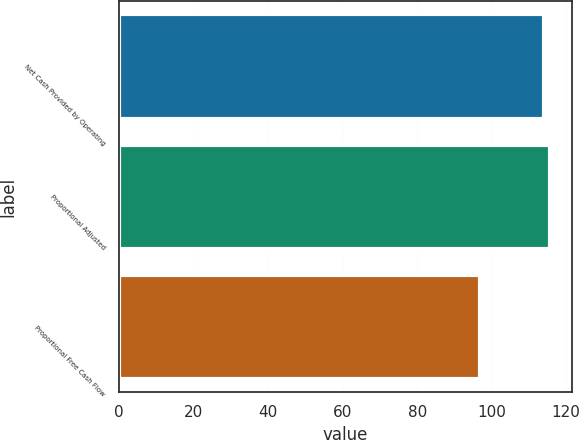Convert chart to OTSL. <chart><loc_0><loc_0><loc_500><loc_500><bar_chart><fcel>Net Cash Provided by Operating<fcel>Proportional Adjusted<fcel>Proportional Free Cash Flow<nl><fcel>114<fcel>115.7<fcel>97<nl></chart> 